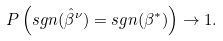Convert formula to latex. <formula><loc_0><loc_0><loc_500><loc_500>P \left ( s g n ( \hat { \beta } ^ { \nu } ) = s g n ( \beta ^ { * } ) \right ) \to 1 .</formula> 